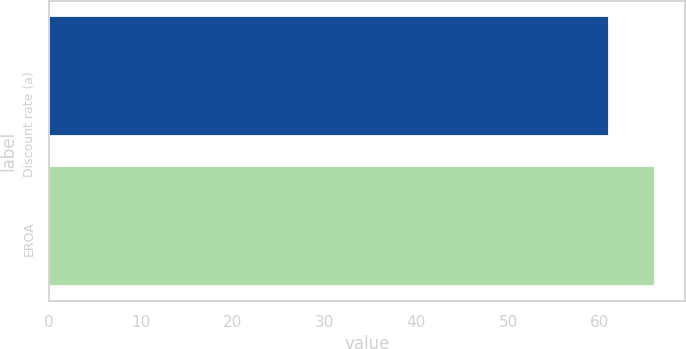Convert chart. <chart><loc_0><loc_0><loc_500><loc_500><bar_chart><fcel>Discount rate (a)<fcel>EROA<nl><fcel>61<fcel>66<nl></chart> 